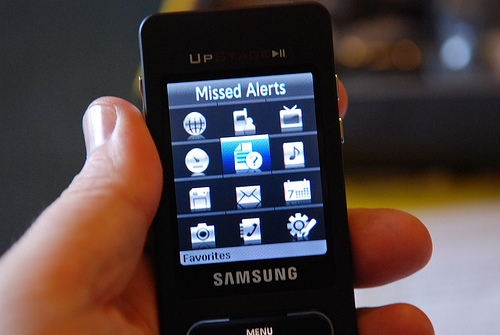How many phones are in the photo? There is one phone visible in the photo. It appears to be an older model Samsung feature phone, held in someone's hand and displaying the main menu screen. 